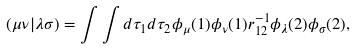Convert formula to latex. <formula><loc_0><loc_0><loc_500><loc_500>( \mu \nu | \lambda \sigma ) = \int \int d \tau _ { 1 } d \tau _ { 2 } \phi _ { \mu } ( 1 ) \phi _ { \nu } ( 1 ) r _ { 1 2 } ^ { - 1 } \phi _ { \lambda } ( 2 ) \phi _ { \sigma } ( 2 ) ,</formula> 